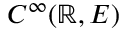<formula> <loc_0><loc_0><loc_500><loc_500>C ^ { \infty } ( \mathbb { R } , E )</formula> 